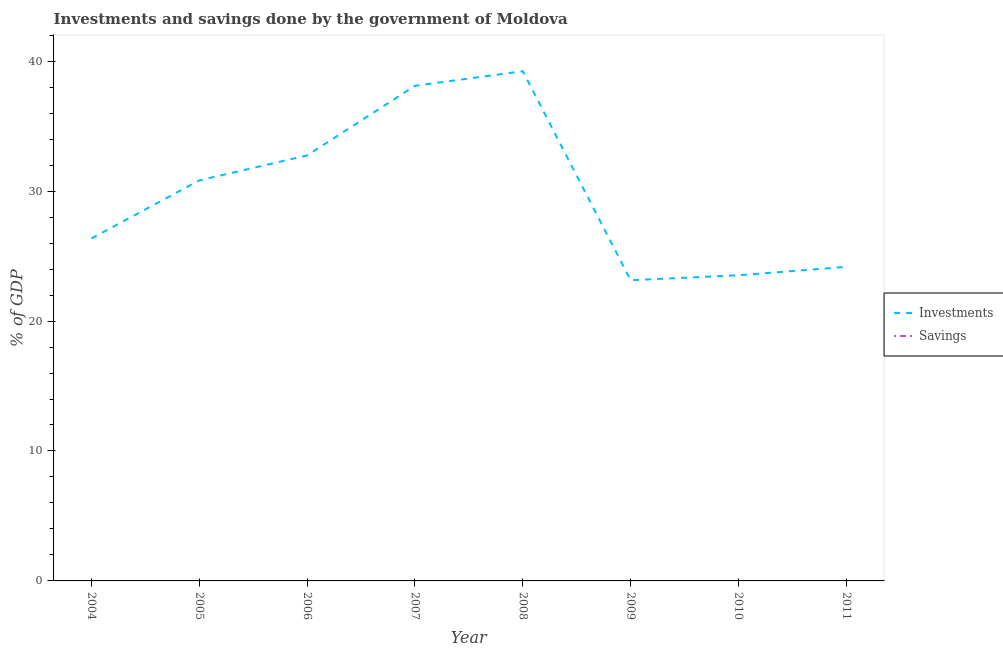How many different coloured lines are there?
Ensure brevity in your answer.  1. Is the number of lines equal to the number of legend labels?
Keep it short and to the point. No. What is the investments of government in 2007?
Provide a succinct answer. 38.11. Across all years, what is the maximum investments of government?
Ensure brevity in your answer.  39.23. Across all years, what is the minimum savings of government?
Offer a terse response. 0. In which year was the investments of government maximum?
Your answer should be compact. 2008. What is the total investments of government in the graph?
Make the answer very short. 238.1. What is the difference between the investments of government in 2009 and that in 2010?
Provide a short and direct response. -0.38. What is the difference between the savings of government in 2006 and the investments of government in 2010?
Ensure brevity in your answer.  -23.52. In how many years, is the savings of government greater than 16 %?
Your answer should be very brief. 0. What is the ratio of the investments of government in 2008 to that in 2010?
Offer a very short reply. 1.67. Is the investments of government in 2004 less than that in 2007?
Keep it short and to the point. Yes. What is the difference between the highest and the second highest investments of government?
Your response must be concise. 1.12. What is the difference between the highest and the lowest investments of government?
Provide a succinct answer. 16.09. Does the investments of government monotonically increase over the years?
Make the answer very short. No. Is the savings of government strictly greater than the investments of government over the years?
Provide a short and direct response. No. How many lines are there?
Your response must be concise. 1. What is the difference between two consecutive major ticks on the Y-axis?
Your response must be concise. 10. Are the values on the major ticks of Y-axis written in scientific E-notation?
Your response must be concise. No. Does the graph contain any zero values?
Your answer should be very brief. Yes. Does the graph contain grids?
Offer a terse response. No. Where does the legend appear in the graph?
Your answer should be compact. Center right. How many legend labels are there?
Offer a terse response. 2. How are the legend labels stacked?
Your answer should be very brief. Vertical. What is the title of the graph?
Your response must be concise. Investments and savings done by the government of Moldova. What is the label or title of the X-axis?
Your response must be concise. Year. What is the label or title of the Y-axis?
Provide a succinct answer. % of GDP. What is the % of GDP of Investments in 2004?
Offer a very short reply. 26.36. What is the % of GDP in Savings in 2004?
Keep it short and to the point. 0. What is the % of GDP of Investments in 2005?
Offer a terse response. 30.83. What is the % of GDP of Investments in 2006?
Ensure brevity in your answer.  32.75. What is the % of GDP in Investments in 2007?
Offer a terse response. 38.11. What is the % of GDP in Investments in 2008?
Your answer should be compact. 39.23. What is the % of GDP in Savings in 2008?
Provide a short and direct response. 0. What is the % of GDP in Investments in 2009?
Your answer should be very brief. 23.14. What is the % of GDP in Savings in 2009?
Provide a short and direct response. 0. What is the % of GDP of Investments in 2010?
Your answer should be very brief. 23.52. What is the % of GDP in Savings in 2010?
Keep it short and to the point. 0. What is the % of GDP of Investments in 2011?
Make the answer very short. 24.17. Across all years, what is the maximum % of GDP in Investments?
Make the answer very short. 39.23. Across all years, what is the minimum % of GDP of Investments?
Provide a short and direct response. 23.14. What is the total % of GDP of Investments in the graph?
Your answer should be very brief. 238.1. What is the difference between the % of GDP in Investments in 2004 and that in 2005?
Make the answer very short. -4.47. What is the difference between the % of GDP of Investments in 2004 and that in 2006?
Provide a short and direct response. -6.39. What is the difference between the % of GDP in Investments in 2004 and that in 2007?
Ensure brevity in your answer.  -11.75. What is the difference between the % of GDP in Investments in 2004 and that in 2008?
Keep it short and to the point. -12.87. What is the difference between the % of GDP of Investments in 2004 and that in 2009?
Ensure brevity in your answer.  3.22. What is the difference between the % of GDP in Investments in 2004 and that in 2010?
Provide a succinct answer. 2.83. What is the difference between the % of GDP of Investments in 2004 and that in 2011?
Offer a very short reply. 2.19. What is the difference between the % of GDP of Investments in 2005 and that in 2006?
Your answer should be very brief. -1.92. What is the difference between the % of GDP of Investments in 2005 and that in 2007?
Ensure brevity in your answer.  -7.28. What is the difference between the % of GDP in Investments in 2005 and that in 2008?
Provide a succinct answer. -8.4. What is the difference between the % of GDP of Investments in 2005 and that in 2009?
Your response must be concise. 7.68. What is the difference between the % of GDP of Investments in 2005 and that in 2010?
Give a very brief answer. 7.3. What is the difference between the % of GDP in Investments in 2005 and that in 2011?
Make the answer very short. 6.66. What is the difference between the % of GDP of Investments in 2006 and that in 2007?
Provide a short and direct response. -5.36. What is the difference between the % of GDP of Investments in 2006 and that in 2008?
Provide a short and direct response. -6.48. What is the difference between the % of GDP of Investments in 2006 and that in 2009?
Offer a very short reply. 9.61. What is the difference between the % of GDP in Investments in 2006 and that in 2010?
Your answer should be very brief. 9.22. What is the difference between the % of GDP in Investments in 2006 and that in 2011?
Your answer should be very brief. 8.58. What is the difference between the % of GDP in Investments in 2007 and that in 2008?
Your answer should be compact. -1.12. What is the difference between the % of GDP of Investments in 2007 and that in 2009?
Provide a short and direct response. 14.96. What is the difference between the % of GDP of Investments in 2007 and that in 2010?
Your answer should be very brief. 14.58. What is the difference between the % of GDP of Investments in 2007 and that in 2011?
Make the answer very short. 13.94. What is the difference between the % of GDP of Investments in 2008 and that in 2009?
Offer a terse response. 16.09. What is the difference between the % of GDP of Investments in 2008 and that in 2010?
Give a very brief answer. 15.7. What is the difference between the % of GDP in Investments in 2008 and that in 2011?
Provide a short and direct response. 15.06. What is the difference between the % of GDP in Investments in 2009 and that in 2010?
Provide a succinct answer. -0.38. What is the difference between the % of GDP in Investments in 2009 and that in 2011?
Provide a succinct answer. -1.03. What is the difference between the % of GDP in Investments in 2010 and that in 2011?
Your response must be concise. -0.65. What is the average % of GDP of Investments per year?
Your answer should be very brief. 29.76. What is the ratio of the % of GDP in Investments in 2004 to that in 2005?
Give a very brief answer. 0.86. What is the ratio of the % of GDP in Investments in 2004 to that in 2006?
Give a very brief answer. 0.8. What is the ratio of the % of GDP of Investments in 2004 to that in 2007?
Your answer should be compact. 0.69. What is the ratio of the % of GDP in Investments in 2004 to that in 2008?
Provide a succinct answer. 0.67. What is the ratio of the % of GDP of Investments in 2004 to that in 2009?
Your answer should be compact. 1.14. What is the ratio of the % of GDP of Investments in 2004 to that in 2010?
Offer a terse response. 1.12. What is the ratio of the % of GDP of Investments in 2004 to that in 2011?
Provide a succinct answer. 1.09. What is the ratio of the % of GDP of Investments in 2005 to that in 2006?
Keep it short and to the point. 0.94. What is the ratio of the % of GDP in Investments in 2005 to that in 2007?
Ensure brevity in your answer.  0.81. What is the ratio of the % of GDP of Investments in 2005 to that in 2008?
Provide a succinct answer. 0.79. What is the ratio of the % of GDP in Investments in 2005 to that in 2009?
Give a very brief answer. 1.33. What is the ratio of the % of GDP of Investments in 2005 to that in 2010?
Your response must be concise. 1.31. What is the ratio of the % of GDP in Investments in 2005 to that in 2011?
Offer a terse response. 1.28. What is the ratio of the % of GDP of Investments in 2006 to that in 2007?
Your answer should be compact. 0.86. What is the ratio of the % of GDP in Investments in 2006 to that in 2008?
Provide a short and direct response. 0.83. What is the ratio of the % of GDP of Investments in 2006 to that in 2009?
Your response must be concise. 1.42. What is the ratio of the % of GDP of Investments in 2006 to that in 2010?
Ensure brevity in your answer.  1.39. What is the ratio of the % of GDP in Investments in 2006 to that in 2011?
Offer a terse response. 1.35. What is the ratio of the % of GDP in Investments in 2007 to that in 2008?
Offer a very short reply. 0.97. What is the ratio of the % of GDP of Investments in 2007 to that in 2009?
Make the answer very short. 1.65. What is the ratio of the % of GDP of Investments in 2007 to that in 2010?
Your response must be concise. 1.62. What is the ratio of the % of GDP in Investments in 2007 to that in 2011?
Ensure brevity in your answer.  1.58. What is the ratio of the % of GDP in Investments in 2008 to that in 2009?
Make the answer very short. 1.7. What is the ratio of the % of GDP of Investments in 2008 to that in 2010?
Give a very brief answer. 1.67. What is the ratio of the % of GDP in Investments in 2008 to that in 2011?
Your answer should be very brief. 1.62. What is the ratio of the % of GDP in Investments in 2009 to that in 2010?
Provide a succinct answer. 0.98. What is the ratio of the % of GDP in Investments in 2009 to that in 2011?
Offer a very short reply. 0.96. What is the ratio of the % of GDP in Investments in 2010 to that in 2011?
Provide a short and direct response. 0.97. What is the difference between the highest and the second highest % of GDP of Investments?
Your response must be concise. 1.12. What is the difference between the highest and the lowest % of GDP of Investments?
Ensure brevity in your answer.  16.09. 